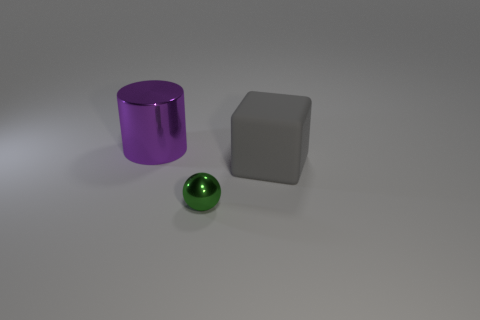What color is the tiny metallic ball?
Ensure brevity in your answer.  Green. What is the shape of the tiny object that is the same material as the cylinder?
Offer a terse response. Sphere. There is a metal thing in front of the purple metal object; is it the same size as the large gray rubber thing?
Your response must be concise. No. How many things are either big objects that are in front of the purple object or large objects that are on the left side of the tiny thing?
Your answer should be compact. 2. How many shiny objects are tiny cubes or tiny green objects?
Make the answer very short. 1. The small shiny object is what shape?
Offer a very short reply. Sphere. Is there anything else that has the same material as the gray block?
Your response must be concise. No. Does the cube have the same material as the small object?
Your response must be concise. No. There is a object that is behind the large thing in front of the purple shiny cylinder; is there a rubber object left of it?
Your answer should be very brief. No. What number of other objects are the same shape as the small thing?
Your answer should be very brief. 0. 